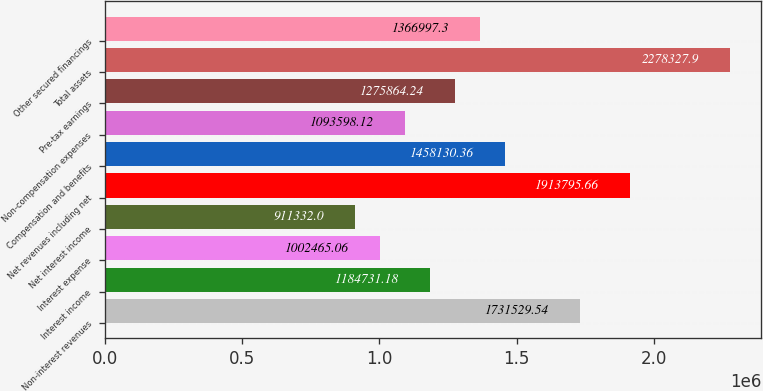<chart> <loc_0><loc_0><loc_500><loc_500><bar_chart><fcel>Non-interest revenues<fcel>Interest income<fcel>Interest expense<fcel>Net interest income<fcel>Net revenues including net<fcel>Compensation and benefits<fcel>Non-compensation expenses<fcel>Pre-tax earnings<fcel>Total assets<fcel>Other secured financings<nl><fcel>1.73153e+06<fcel>1.18473e+06<fcel>1.00247e+06<fcel>911332<fcel>1.9138e+06<fcel>1.45813e+06<fcel>1.0936e+06<fcel>1.27586e+06<fcel>2.27833e+06<fcel>1.367e+06<nl></chart> 